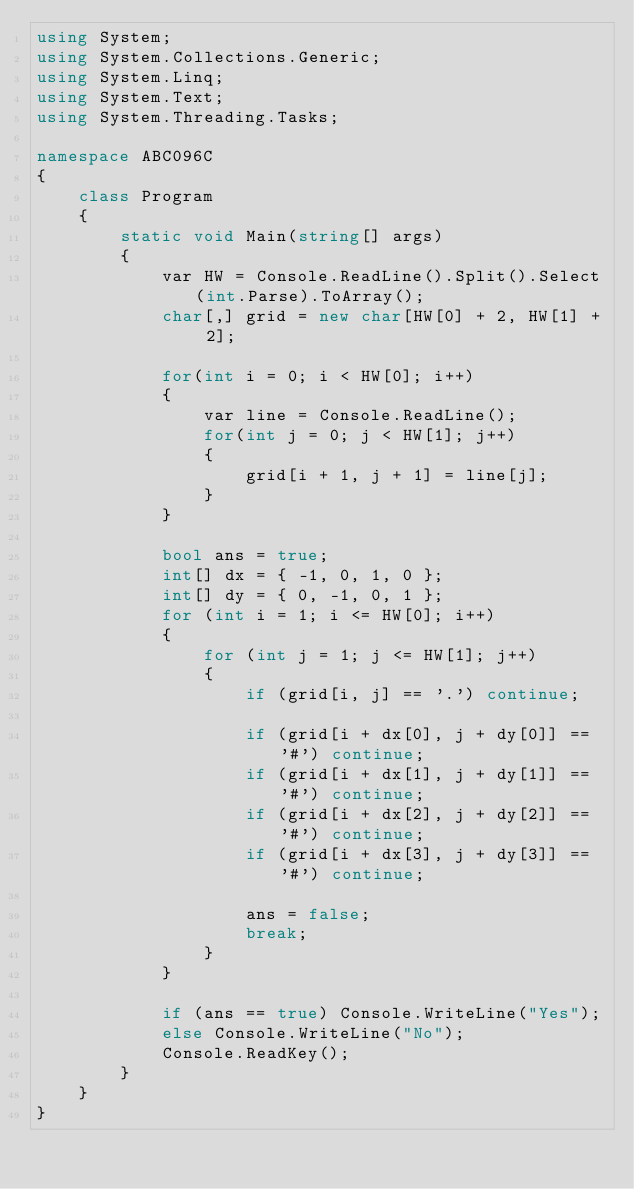Convert code to text. <code><loc_0><loc_0><loc_500><loc_500><_C#_>using System;
using System.Collections.Generic;
using System.Linq;
using System.Text;
using System.Threading.Tasks;

namespace ABC096C
{
    class Program
    {
        static void Main(string[] args)
        {
            var HW = Console.ReadLine().Split().Select(int.Parse).ToArray();
            char[,] grid = new char[HW[0] + 2, HW[1] + 2];

            for(int i = 0; i < HW[0]; i++)
            {
                var line = Console.ReadLine();
                for(int j = 0; j < HW[1]; j++)
                {
                    grid[i + 1, j + 1] = line[j];
                }
            }

            bool ans = true;
            int[] dx = { -1, 0, 1, 0 };
            int[] dy = { 0, -1, 0, 1 };
            for (int i = 1; i <= HW[0]; i++)
            {
                for (int j = 1; j <= HW[1]; j++)
                {
                    if (grid[i, j] == '.') continue;

                    if (grid[i + dx[0], j + dy[0]] == '#') continue;
                    if (grid[i + dx[1], j + dy[1]] == '#') continue;
                    if (grid[i + dx[2], j + dy[2]] == '#') continue;
                    if (grid[i + dx[3], j + dy[3]] == '#') continue;

                    ans = false;
                    break;
                }
            }

            if (ans == true) Console.WriteLine("Yes");
            else Console.WriteLine("No");
            Console.ReadKey();
        }
    }
}
</code> 